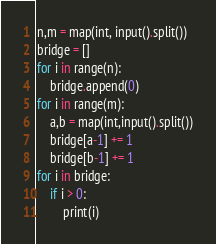Convert code to text. <code><loc_0><loc_0><loc_500><loc_500><_Python_>n,m = map(int, input().split())
bridge = []
for i in range(n):
    bridge.append(0)
for i in range(m):
    a,b = map(int,input().split())
    bridge[a-1] += 1
    bridge[b-1] += 1
for i in bridge:
    if i > 0:
        print(i)
</code> 